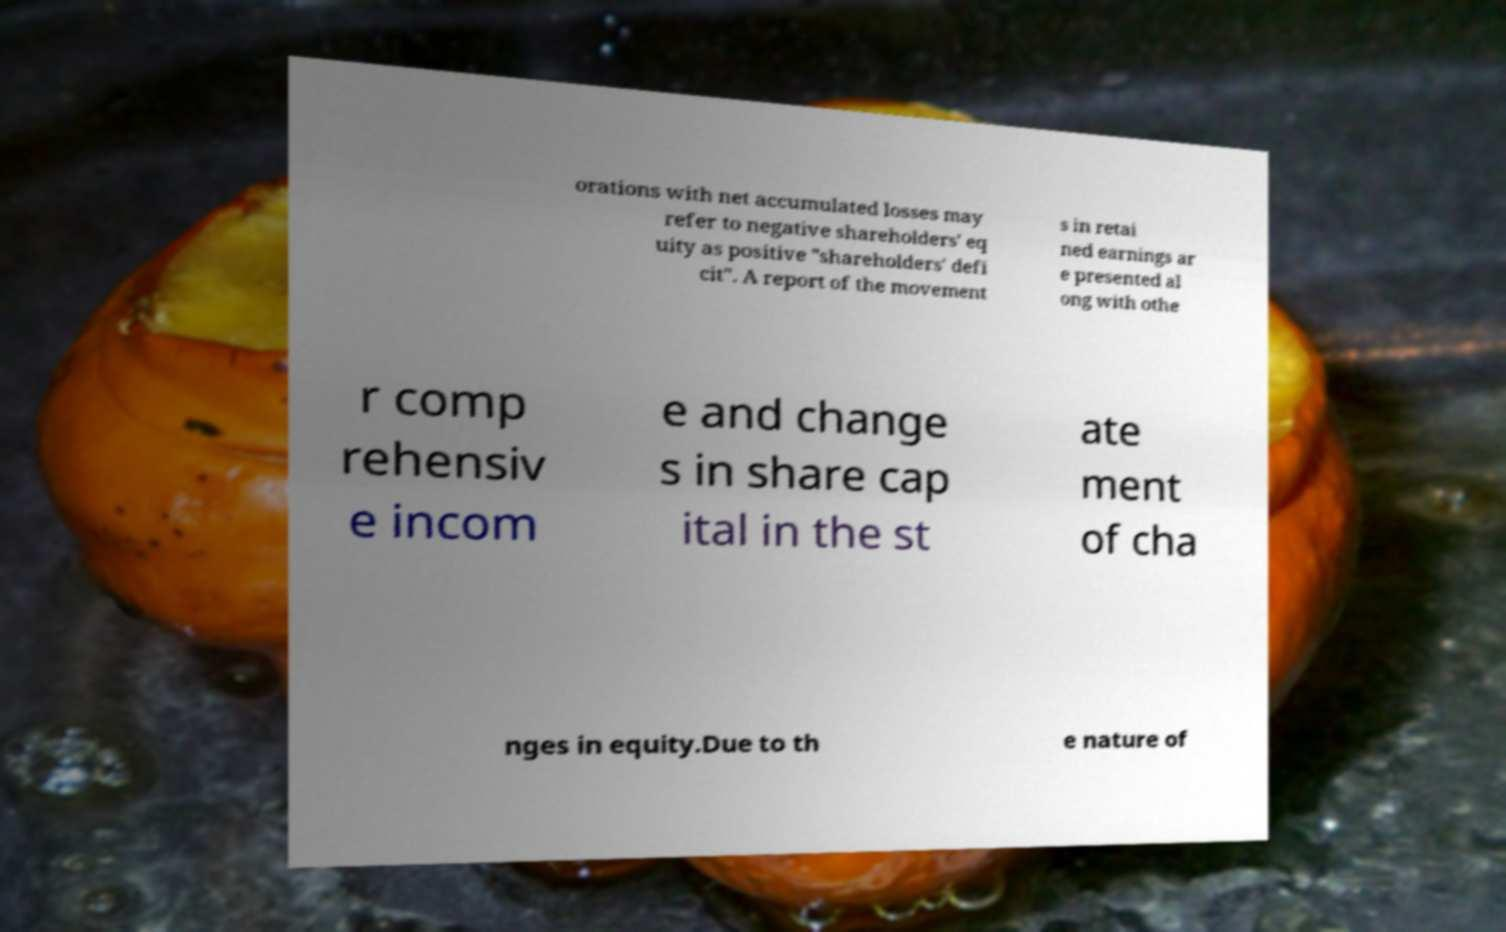For documentation purposes, I need the text within this image transcribed. Could you provide that? orations with net accumulated losses may refer to negative shareholders' eq uity as positive "shareholders' defi cit". A report of the movement s in retai ned earnings ar e presented al ong with othe r comp rehensiv e incom e and change s in share cap ital in the st ate ment of cha nges in equity.Due to th e nature of 